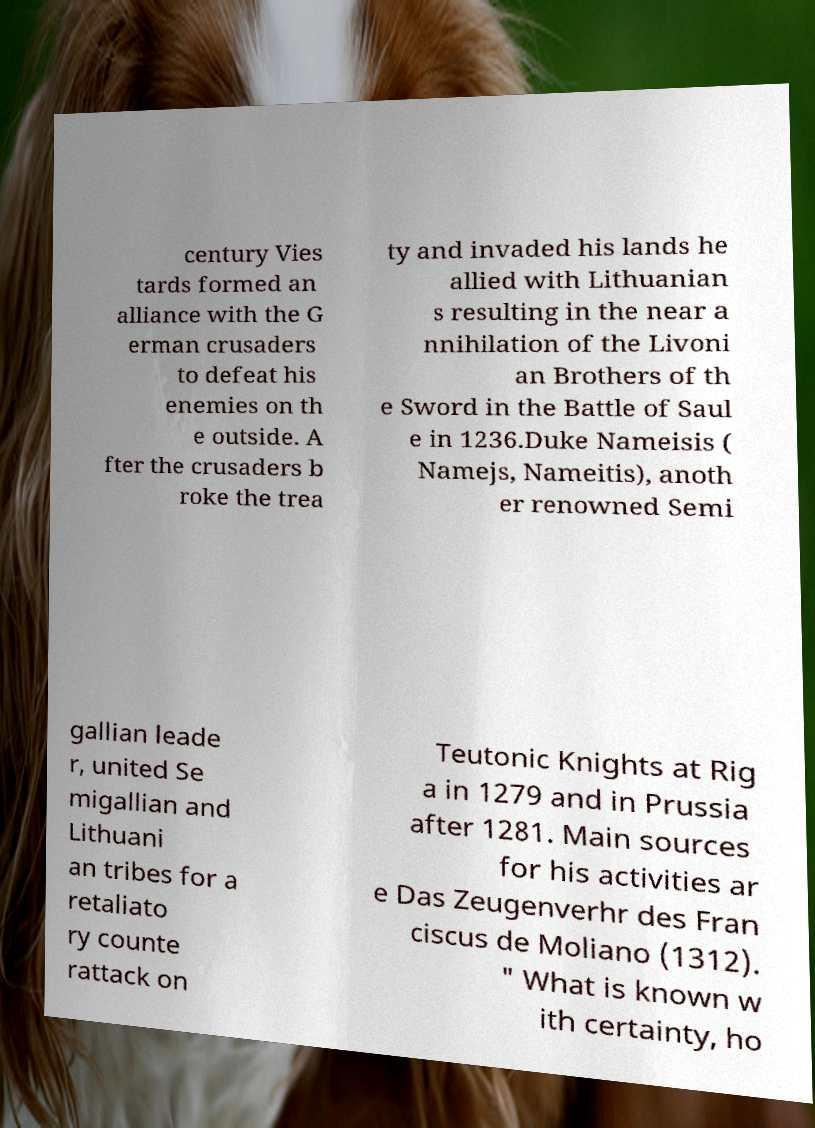I need the written content from this picture converted into text. Can you do that? century Vies tards formed an alliance with the G erman crusaders to defeat his enemies on th e outside. A fter the crusaders b roke the trea ty and invaded his lands he allied with Lithuanian s resulting in the near a nnihilation of the Livoni an Brothers of th e Sword in the Battle of Saul e in 1236.Duke Nameisis ( Namejs, Nameitis), anoth er renowned Semi gallian leade r, united Se migallian and Lithuani an tribes for a retaliato ry counte rattack on Teutonic Knights at Rig a in 1279 and in Prussia after 1281. Main sources for his activities ar e Das Zeugenverhr des Fran ciscus de Moliano (1312). " What is known w ith certainty, ho 